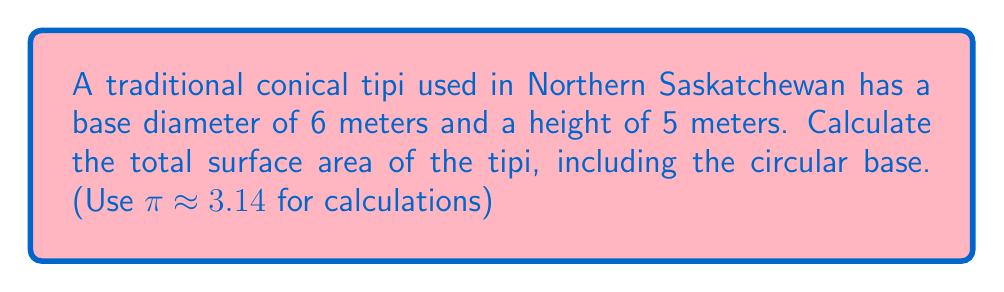Can you answer this question? To solve this problem, we need to calculate the surface area of a cone (the tipi) and add it to the area of its circular base. Let's break it down step-by-step:

1. First, let's identify the known values:
   - Base diameter = 6 m
   - Height = 5 m
   - $\pi \approx 3.14$

2. Calculate the radius of the base:
   $r = \frac{\text{diameter}}{2} = \frac{6}{2} = 3$ m

3. To find the surface area of a cone, we need to calculate the slant height ($s$). We can do this using the Pythagorean theorem:

   $$s = \sqrt{r^2 + h^2} = \sqrt{3^2 + 5^2} = \sqrt{9 + 25} = \sqrt{34} \approx 5.83$ m

4. The surface area of a cone (excluding the base) is given by the formula:
   $$SA_{cone} = \pi r s$$

   Substituting the values:
   $$SA_{cone} = 3.14 \times 3 \times 5.83 \approx 54.89$ m²

5. The area of the circular base is:
   $$A_{base} = \pi r^2 = 3.14 \times 3^2 = 28.26$ m²

6. The total surface area is the sum of the cone's surface area and the base area:
   $$SA_{total} = SA_{cone} + A_{base} = 54.89 + 28.26 = 83.15$ m²

[asy]
import geometry;

size(200);
pair A = (0,0), B = (3,0), C = (0,5);
draw(A--B--C--cycle);
draw(arc(A,3,0,360));
label("6 m", (1.5,-0.5));
label("5 m", (-0.5,2.5));
label("r = 3 m", (1.5,0.2));
</asy]
Answer: The total surface area of the conical tipi, including its base, is approximately 83.15 square meters. 